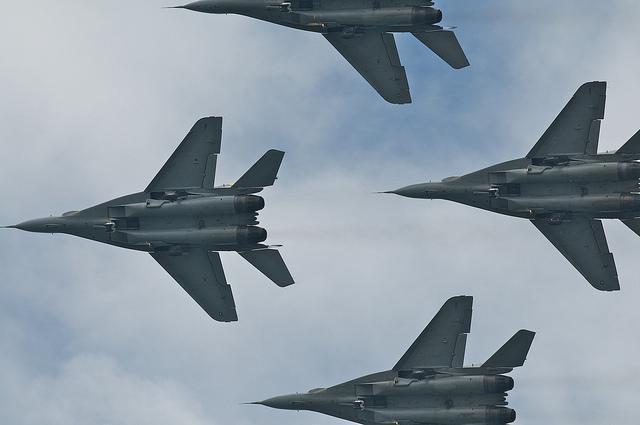The number of items visible in the sky cane be referred to as what?
Pick the correct solution from the four options below to address the question.
Options: Quartet, legion, platoon, brigade. Quartet. 